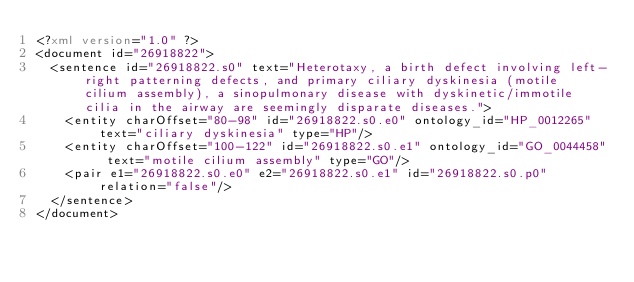Convert code to text. <code><loc_0><loc_0><loc_500><loc_500><_XML_><?xml version="1.0" ?>
<document id="26918822">
  <sentence id="26918822.s0" text="Heterotaxy, a birth defect involving left-right patterning defects, and primary ciliary dyskinesia (motile cilium assembly), a sinopulmonary disease with dyskinetic/immotile cilia in the airway are seemingly disparate diseases.">
    <entity charOffset="80-98" id="26918822.s0.e0" ontology_id="HP_0012265" text="ciliary dyskinesia" type="HP"/>
    <entity charOffset="100-122" id="26918822.s0.e1" ontology_id="GO_0044458" text="motile cilium assembly" type="GO"/>
    <pair e1="26918822.s0.e0" e2="26918822.s0.e1" id="26918822.s0.p0" relation="false"/>
  </sentence>
</document>
</code> 